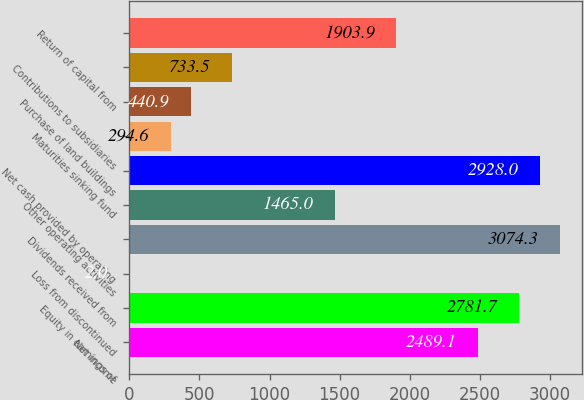Convert chart. <chart><loc_0><loc_0><loc_500><loc_500><bar_chart><fcel>Net income<fcel>Equity in earnings of<fcel>Loss from discontinued<fcel>Dividends received from<fcel>Other operating activities<fcel>Net cash provided by operating<fcel>Maturities sinking fund<fcel>Purchase of land buildings<fcel>Contributions to subsidiaries<fcel>Return of capital from<nl><fcel>2489.1<fcel>2781.7<fcel>2<fcel>3074.3<fcel>1465<fcel>2928<fcel>294.6<fcel>440.9<fcel>733.5<fcel>1903.9<nl></chart> 